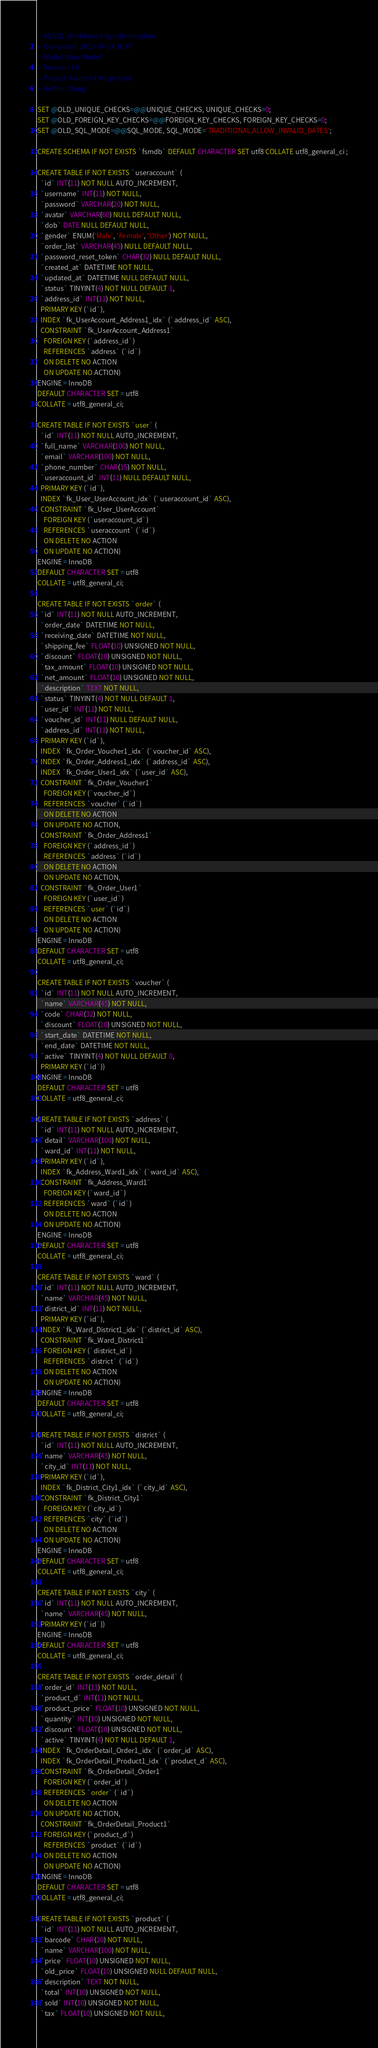Convert code to text. <code><loc_0><loc_0><loc_500><loc_500><_SQL_>-- MySQL Workbench Synchronization
-- Generated: 2015-04-24 10:47
-- Model: New Model
-- Version: 1.0
-- Project: Name of the project
-- Author: Dung

SET @OLD_UNIQUE_CHECKS=@@UNIQUE_CHECKS, UNIQUE_CHECKS=0;
SET @OLD_FOREIGN_KEY_CHECKS=@@FOREIGN_KEY_CHECKS, FOREIGN_KEY_CHECKS=0;
SET @OLD_SQL_MODE=@@SQL_MODE, SQL_MODE='TRADITIONAL,ALLOW_INVALID_DATES';

CREATE SCHEMA IF NOT EXISTS `fsmdb` DEFAULT CHARACTER SET utf8 COLLATE utf8_general_ci ;

CREATE TABLE IF NOT EXISTS `useraccount` (
  `id` INT(11) NOT NULL AUTO_INCREMENT,
  `username` INT(11) NOT NULL,
  `password` VARCHAR(20) NOT NULL,
  `avatar` VARCHAR(60) NULL DEFAULT NULL,
  `dob` DATE NULL DEFAULT NULL,
  `gender` ENUM('Male', 'Female', 'Other') NOT NULL,
  `order_list` VARCHAR(45) NULL DEFAULT NULL,
  `password_reset_token` CHAR(32) NULL DEFAULT NULL,
  `created_at` DATETIME NOT NULL,
  `updated_at` DATETIME NULL DEFAULT NULL,
  `status` TINYINT(4) NOT NULL DEFAULT 1,
  `address_id` INT(11) NOT NULL,
  PRIMARY KEY (`id`),
  INDEX `fk_UserAccount_Address1_idx` (`address_id` ASC),
  CONSTRAINT `fk_UserAccount_Address1`
    FOREIGN KEY (`address_id`)
    REFERENCES `address` (`id`)
    ON DELETE NO ACTION
    ON UPDATE NO ACTION)
ENGINE = InnoDB
DEFAULT CHARACTER SET = utf8
COLLATE = utf8_general_ci;

CREATE TABLE IF NOT EXISTS `user` (
  `id` INT(11) NOT NULL AUTO_INCREMENT,
  `full_name` VARCHAR(100) NOT NULL,
  `email` VARCHAR(100) NOT NULL,
  `phone_number` CHAR(15) NOT NULL,
  `useraccount_id` INT(11) NULL DEFAULT NULL,
  PRIMARY KEY (`id`),
  INDEX `fk_User_UserAccount_idx` (`useraccount_id` ASC),
  CONSTRAINT `fk_User_UserAccount`
    FOREIGN KEY (`useraccount_id`)
    REFERENCES `useraccount` (`id`)
    ON DELETE NO ACTION
    ON UPDATE NO ACTION)
ENGINE = InnoDB
DEFAULT CHARACTER SET = utf8
COLLATE = utf8_general_ci;

CREATE TABLE IF NOT EXISTS `order` (
  `id` INT(11) NOT NULL AUTO_INCREMENT,
  `order_date` DATETIME NOT NULL,
  `receiving_date` DATETIME NOT NULL,
  `shipping_fee` FLOAT(10) UNSIGNED NOT NULL,
  `discount` FLOAT(10) UNSIGNED NOT NULL,
  `tax_amount` FLOAT(10) UNSIGNED NOT NULL,
  `net_amount` FLOAT(10) UNSIGNED NOT NULL,
  `description` TEXT NOT NULL,
  `status` TINYINT(4) NOT NULL DEFAULT 1,
  `user_id` INT(11) NOT NULL,
  `voucher_id` INT(11) NULL DEFAULT NULL,
  `address_id` INT(11) NOT NULL,
  PRIMARY KEY (`id`),
  INDEX `fk_Order_Voucher1_idx` (`voucher_id` ASC),
  INDEX `fk_Order_Address1_idx` (`address_id` ASC),
  INDEX `fk_Order_User1_idx` (`user_id` ASC),
  CONSTRAINT `fk_Order_Voucher1`
    FOREIGN KEY (`voucher_id`)
    REFERENCES `voucher` (`id`)
    ON DELETE NO ACTION
    ON UPDATE NO ACTION,
  CONSTRAINT `fk_Order_Address1`
    FOREIGN KEY (`address_id`)
    REFERENCES `address` (`id`)
    ON DELETE NO ACTION
    ON UPDATE NO ACTION,
  CONSTRAINT `fk_Order_User1`
    FOREIGN KEY (`user_id`)
    REFERENCES `user` (`id`)
    ON DELETE NO ACTION
    ON UPDATE NO ACTION)
ENGINE = InnoDB
DEFAULT CHARACTER SET = utf8
COLLATE = utf8_general_ci;

CREATE TABLE IF NOT EXISTS `voucher` (
  `id` INT(11) NOT NULL AUTO_INCREMENT,
  `name` VARCHAR(45) NOT NULL,
  `code` CHAR(32) NOT NULL,
  `discount` FLOAT(10) UNSIGNED NOT NULL,
  `start_date` DATETIME NOT NULL,
  `end_date` DATETIME NOT NULL,
  `active` TINYINT(4) NOT NULL DEFAULT 0,
  PRIMARY KEY (`id`))
ENGINE = InnoDB
DEFAULT CHARACTER SET = utf8
COLLATE = utf8_general_ci;

CREATE TABLE IF NOT EXISTS `address` (
  `id` INT(11) NOT NULL AUTO_INCREMENT,
  `detail` VARCHAR(100) NOT NULL,
  `ward_id` INT(11) NOT NULL,
  PRIMARY KEY (`id`),
  INDEX `fk_Address_Ward1_idx` (`ward_id` ASC),
  CONSTRAINT `fk_Address_Ward1`
    FOREIGN KEY (`ward_id`)
    REFERENCES `ward` (`id`)
    ON DELETE NO ACTION
    ON UPDATE NO ACTION)
ENGINE = InnoDB
DEFAULT CHARACTER SET = utf8
COLLATE = utf8_general_ci;

CREATE TABLE IF NOT EXISTS `ward` (
  `id` INT(11) NOT NULL AUTO_INCREMENT,
  `name` VARCHAR(45) NOT NULL,
  `district_id` INT(11) NOT NULL,
  PRIMARY KEY (`id`),
  INDEX `fk_Ward_District1_idx` (`district_id` ASC),
  CONSTRAINT `fk_Ward_District1`
    FOREIGN KEY (`district_id`)
    REFERENCES `district` (`id`)
    ON DELETE NO ACTION
    ON UPDATE NO ACTION)
ENGINE = InnoDB
DEFAULT CHARACTER SET = utf8
COLLATE = utf8_general_ci;

CREATE TABLE IF NOT EXISTS `district` (
  `id` INT(11) NOT NULL AUTO_INCREMENT,
  `name` VARCHAR(45) NOT NULL,
  `city_id` INT(11) NOT NULL,
  PRIMARY KEY (`id`),
  INDEX `fk_District_City1_idx` (`city_id` ASC),
  CONSTRAINT `fk_District_City1`
    FOREIGN KEY (`city_id`)
    REFERENCES `city` (`id`)
    ON DELETE NO ACTION
    ON UPDATE NO ACTION)
ENGINE = InnoDB
DEFAULT CHARACTER SET = utf8
COLLATE = utf8_general_ci;

CREATE TABLE IF NOT EXISTS `city` (
  `id` INT(11) NOT NULL AUTO_INCREMENT,
  `name` VARCHAR(45) NOT NULL,
  PRIMARY KEY (`id`))
ENGINE = InnoDB
DEFAULT CHARACTER SET = utf8
COLLATE = utf8_general_ci;

CREATE TABLE IF NOT EXISTS `order_detail` (
  `order_id` INT(11) NOT NULL,
  `product_d` INT(11) NOT NULL,
  `product_price` FLOAT(10) UNSIGNED NOT NULL,
  `quantity` INT(10) UNSIGNED NOT NULL,
  `discount` FLOAT(10) UNSIGNED NOT NULL,
  `active` TINYINT(4) NOT NULL DEFAULT 1,
  INDEX `fk_OrderDetail_Order1_idx` (`order_id` ASC),
  INDEX `fk_OrderDetail_Product1_idx` (`product_d` ASC),
  CONSTRAINT `fk_OrderDetail_Order1`
    FOREIGN KEY (`order_id`)
    REFERENCES `order` (`id`)
    ON DELETE NO ACTION
    ON UPDATE NO ACTION,
  CONSTRAINT `fk_OrderDetail_Product1`
    FOREIGN KEY (`product_d`)
    REFERENCES `product` (`id`)
    ON DELETE NO ACTION
    ON UPDATE NO ACTION)
ENGINE = InnoDB
DEFAULT CHARACTER SET = utf8
COLLATE = utf8_general_ci;

CREATE TABLE IF NOT EXISTS `product` (
  `id` INT(11) NOT NULL AUTO_INCREMENT,
  `barcode` CHAR(20) NOT NULL,
  `name` VARCHAR(100) NOT NULL,
  `price` FLOAT(10) UNSIGNED NOT NULL,
  `old_price` FLOAT(10) UNSIGNED NULL DEFAULT NULL,
  `description` TEXT NOT NULL,
  `total` INT(10) UNSIGNED NOT NULL,
  `sold` INT(10) UNSIGNED NOT NULL,
  `tax` FLOAT(10) UNSIGNED NOT NULL,</code> 